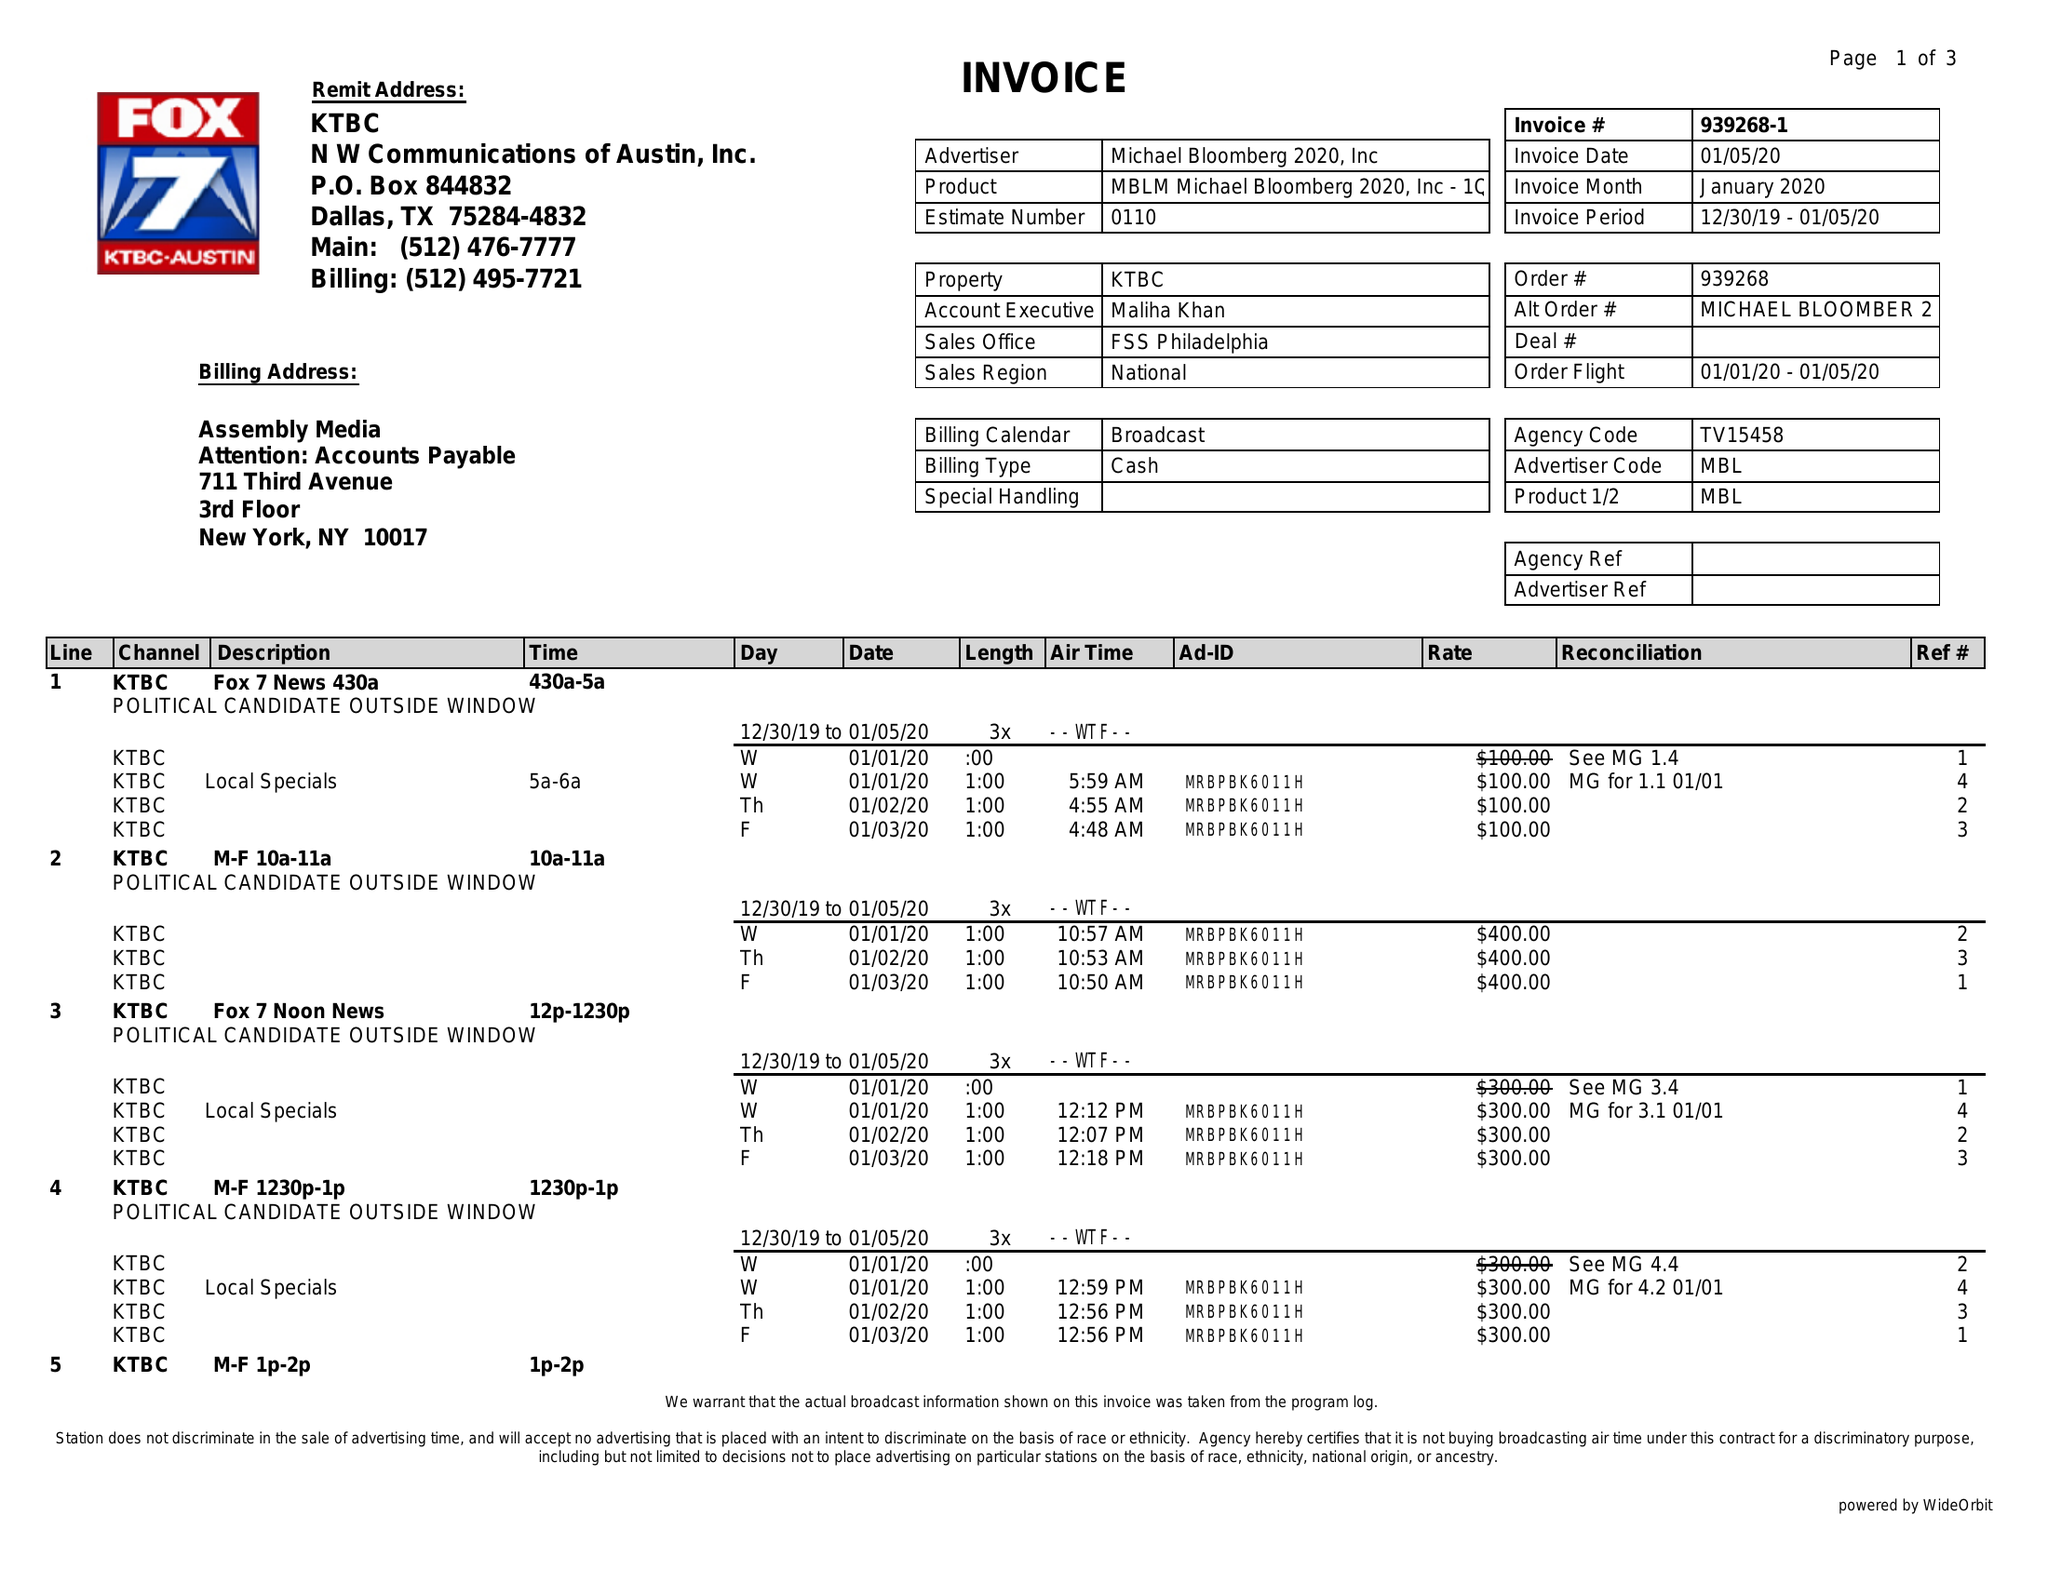What is the value for the flight_to?
Answer the question using a single word or phrase. 01/05/20 